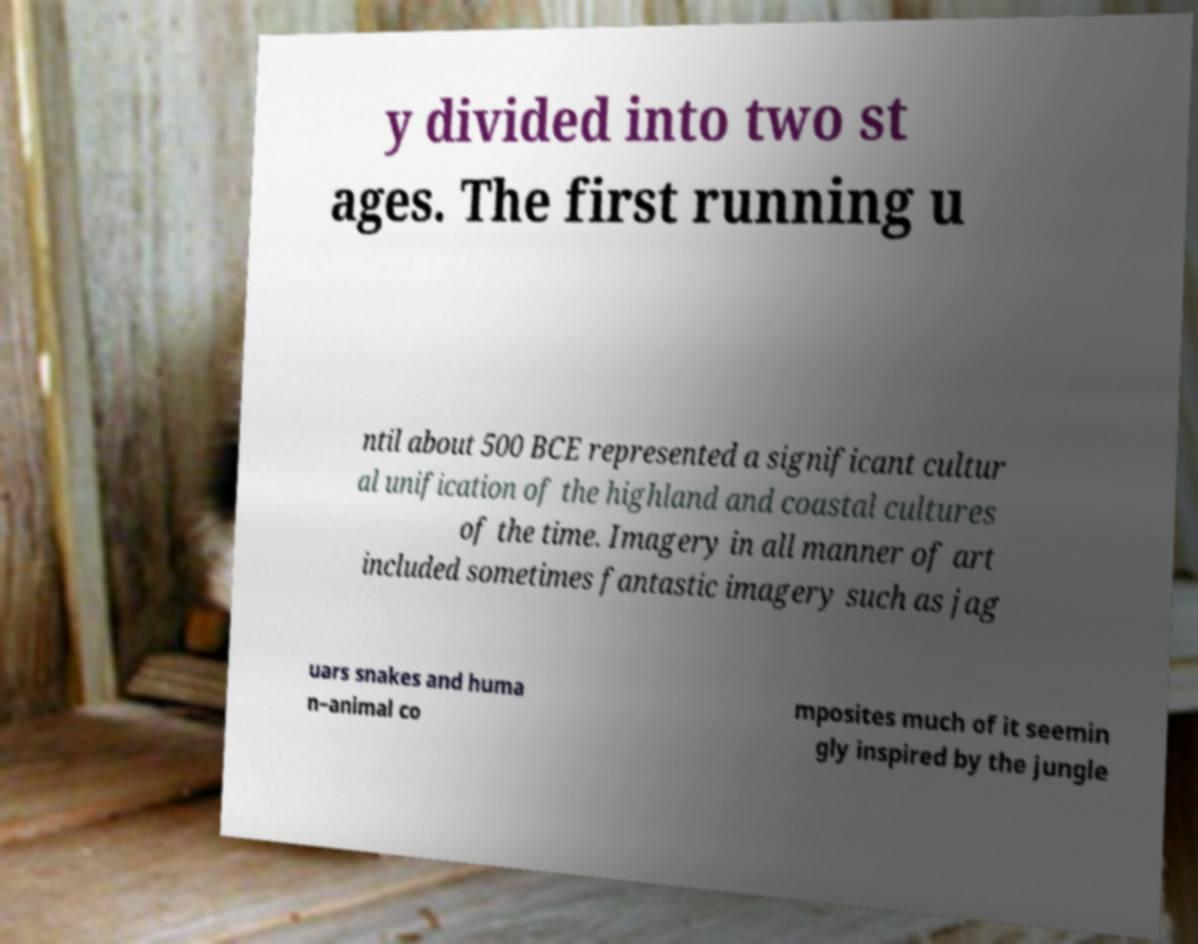Can you read and provide the text displayed in the image?This photo seems to have some interesting text. Can you extract and type it out for me? y divided into two st ages. The first running u ntil about 500 BCE represented a significant cultur al unification of the highland and coastal cultures of the time. Imagery in all manner of art included sometimes fantastic imagery such as jag uars snakes and huma n–animal co mposites much of it seemin gly inspired by the jungle 